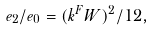Convert formula to latex. <formula><loc_0><loc_0><loc_500><loc_500>e _ { 2 } / e _ { 0 } = ( k ^ { F } W ) ^ { 2 } / 1 2 ,</formula> 